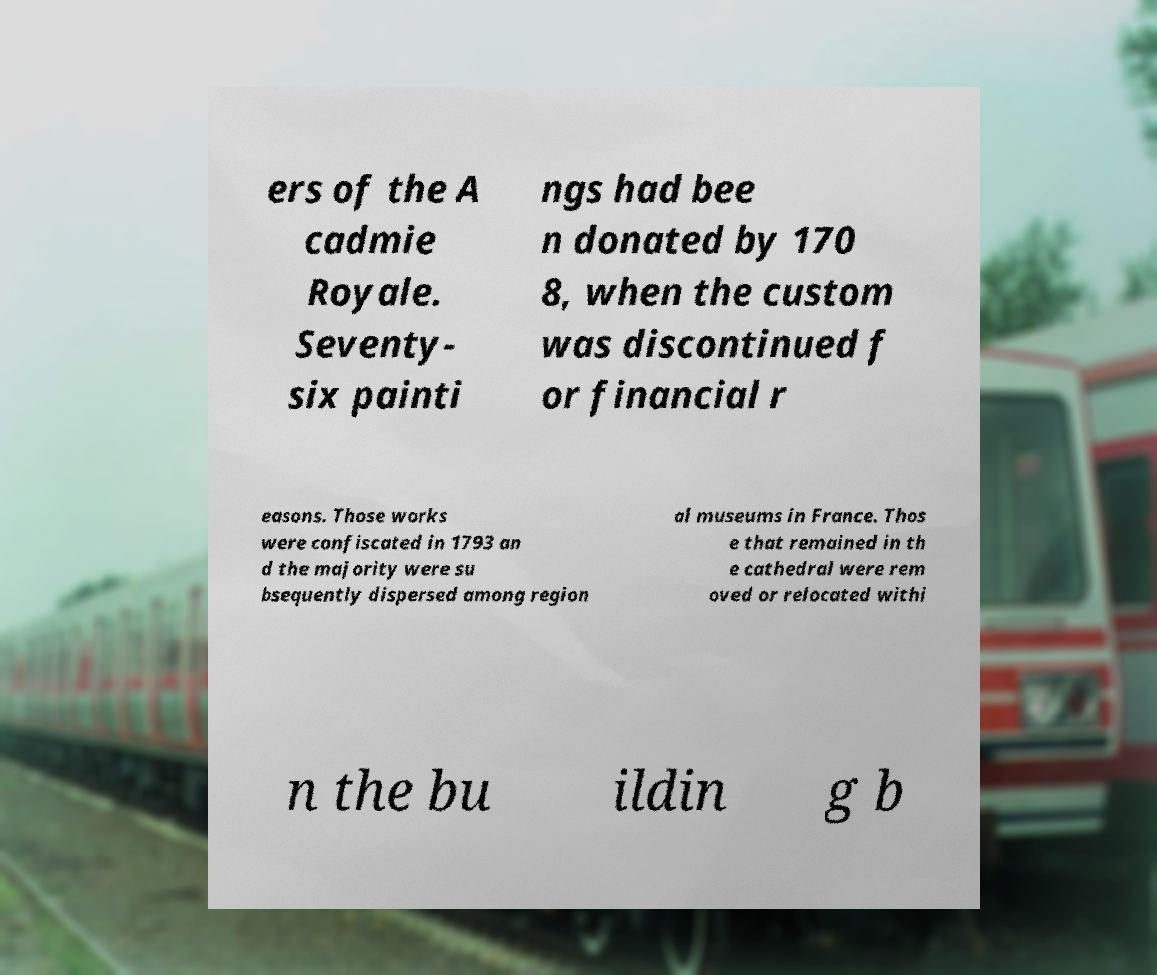What messages or text are displayed in this image? I need them in a readable, typed format. ers of the A cadmie Royale. Seventy- six painti ngs had bee n donated by 170 8, when the custom was discontinued f or financial r easons. Those works were confiscated in 1793 an d the majority were su bsequently dispersed among region al museums in France. Thos e that remained in th e cathedral were rem oved or relocated withi n the bu ildin g b 